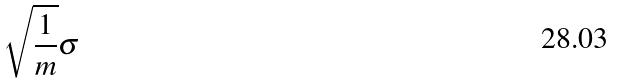Convert formula to latex. <formula><loc_0><loc_0><loc_500><loc_500>\sqrt { \frac { 1 } { m } } \sigma</formula> 